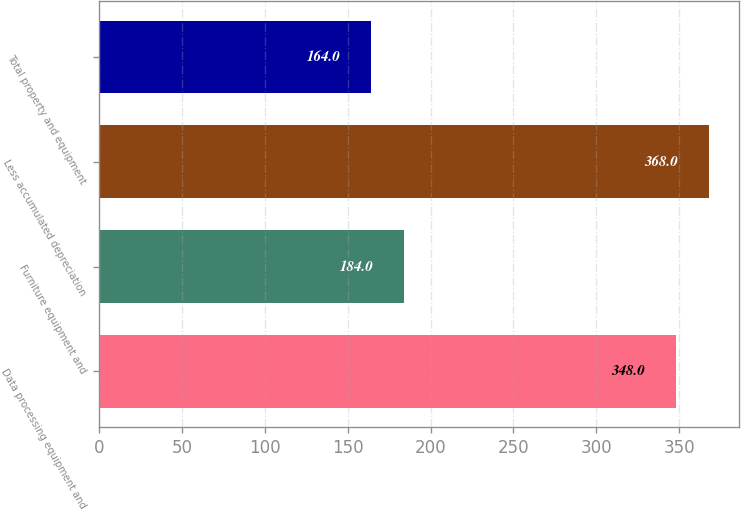Convert chart. <chart><loc_0><loc_0><loc_500><loc_500><bar_chart><fcel>Data processing equipment and<fcel>Furniture equipment and<fcel>Less accumulated depreciation<fcel>Total property and equipment<nl><fcel>348<fcel>184<fcel>368<fcel>164<nl></chart> 